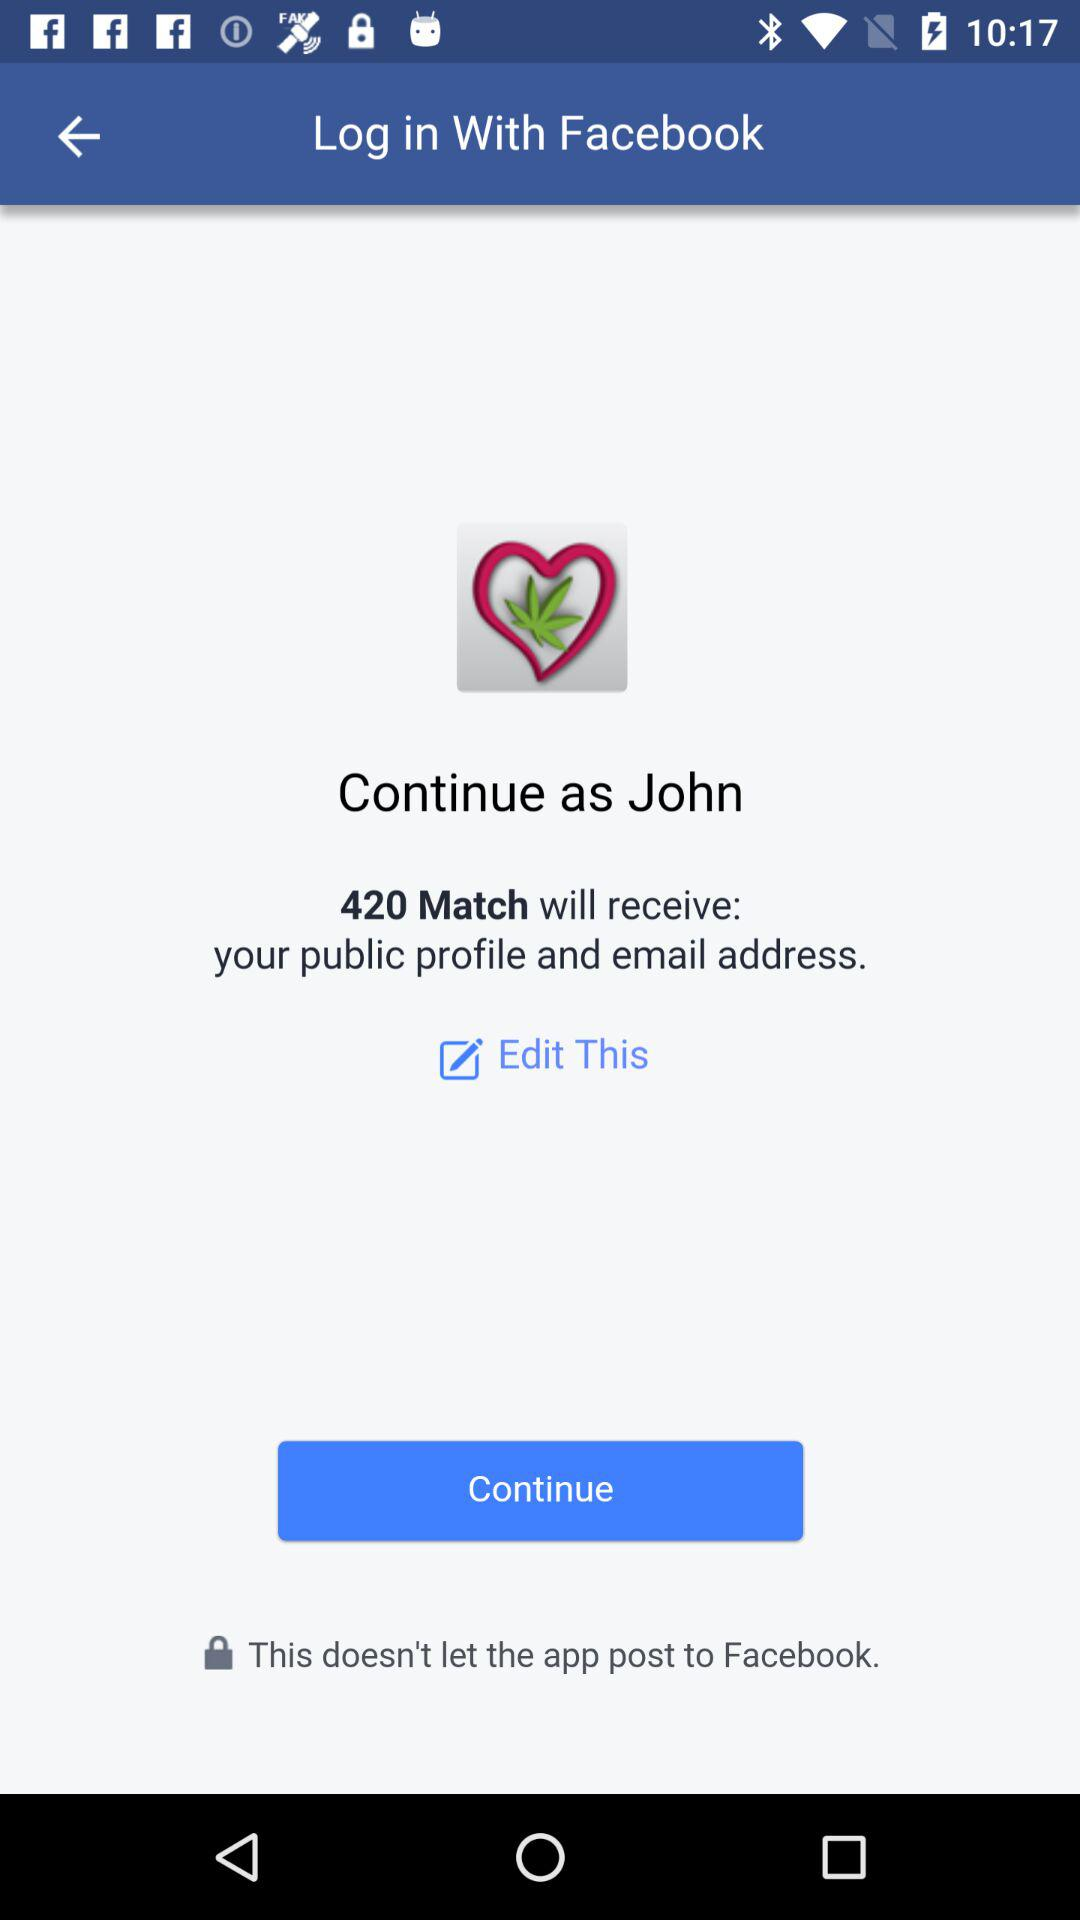What's the user name? The user name is John. 